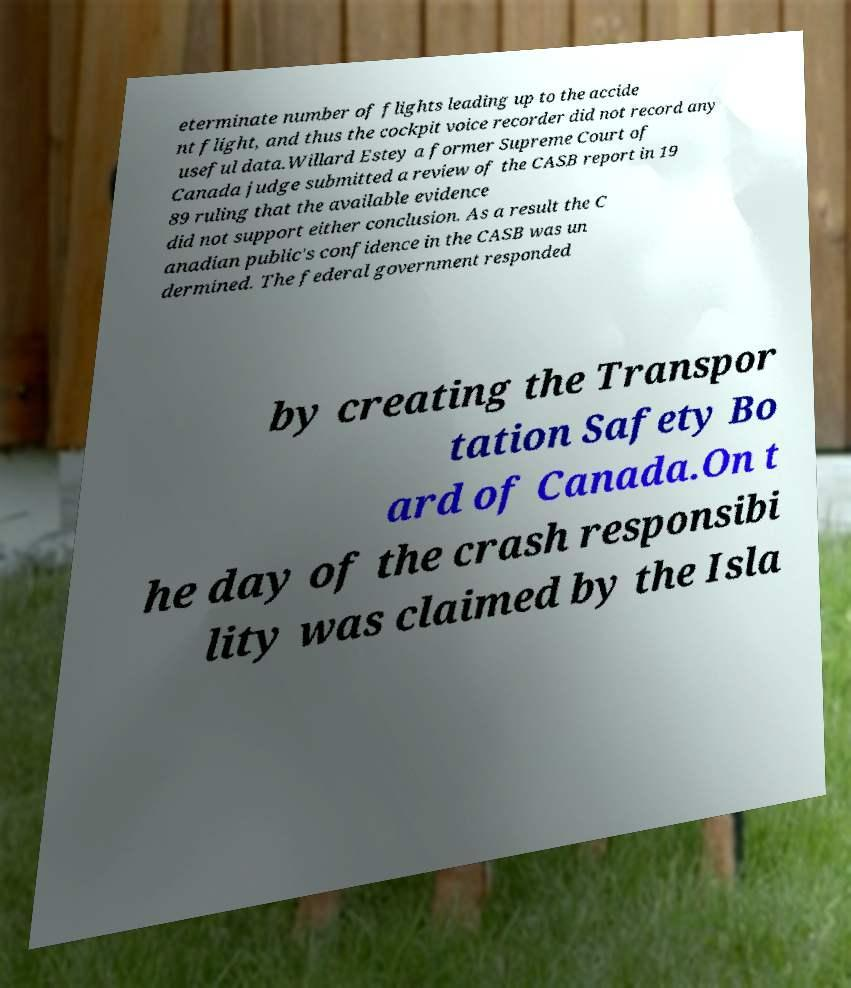Could you assist in decoding the text presented in this image and type it out clearly? eterminate number of flights leading up to the accide nt flight, and thus the cockpit voice recorder did not record any useful data.Willard Estey a former Supreme Court of Canada judge submitted a review of the CASB report in 19 89 ruling that the available evidence did not support either conclusion. As a result the C anadian public's confidence in the CASB was un dermined. The federal government responded by creating the Transpor tation Safety Bo ard of Canada.On t he day of the crash responsibi lity was claimed by the Isla 